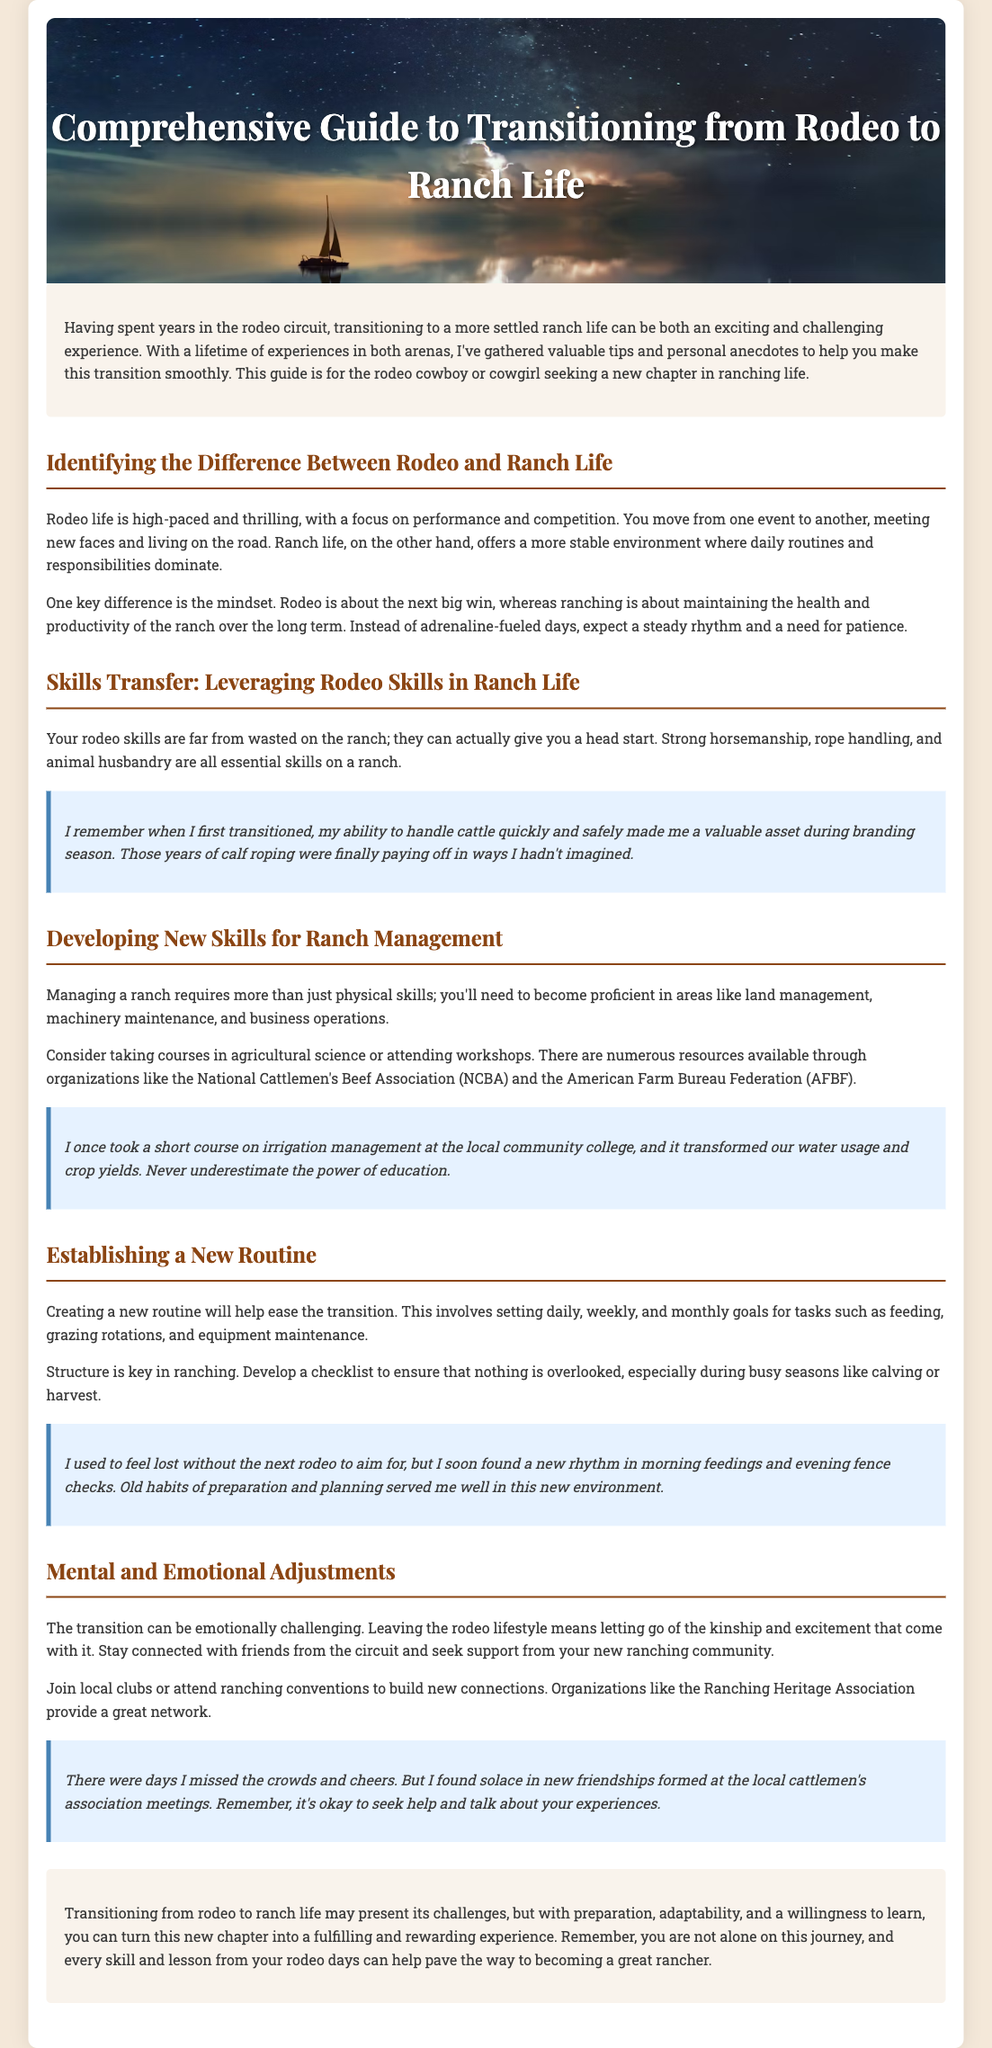What is the title of the guide? The title is stated in the header section of the document.
Answer: Comprehensive Guide to Transitioning from Rodeo to Ranch Life What are two areas you need to develop new skills in for ranch management? The document lists areas where new skills are needed.
Answer: Land management and machinery maintenance What is a key difference between rodeo life and ranch life? The document explains the differences in lifestyle and mindset between the two.
Answer: Daily routines and responsibilities Which organization is mentioned as a resource for ranching information? The document provides names of organizations for education and support.
Answer: National Cattlemen's Beef Association What personal experience is shared regarding irrigation management? One personal anecdote mentions the impact of education on ranching practices.
Answer: Transformed water usage and crop yields What is a suggested way to establish a new routine on the ranch? The document advises on how to create a structured routine for ranching tasks.
Answer: Setting daily, weekly, and monthly goals What emotion might one feel when leaving the rodeo lifestyle? The document discusses the emotional aspects of transitioning.
Answer: Sadness What type of community is recommended to join for support? The document emphasizes the importance of community and connections in ranching.
Answer: Local clubs or ranching conventions 